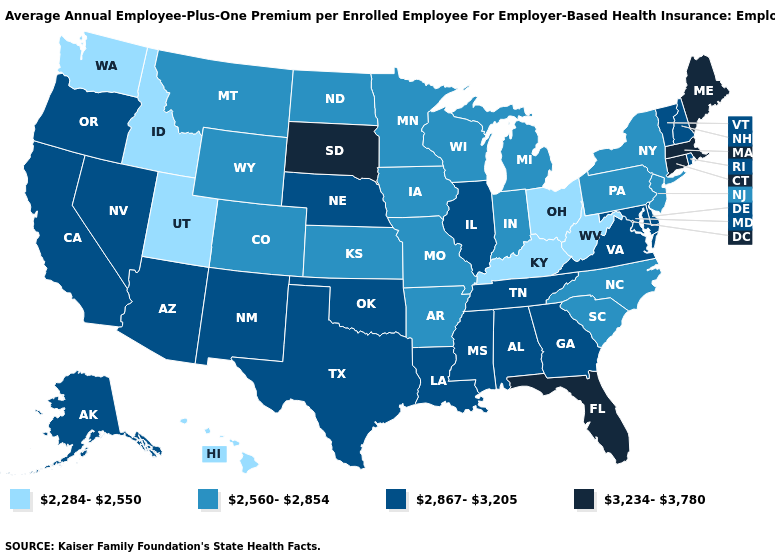Among the states that border West Virginia , which have the lowest value?
Concise answer only. Kentucky, Ohio. Which states have the highest value in the USA?
Give a very brief answer. Connecticut, Florida, Maine, Massachusetts, South Dakota. Does the first symbol in the legend represent the smallest category?
Be succinct. Yes. Among the states that border New Mexico , does Oklahoma have the lowest value?
Concise answer only. No. Which states hav the highest value in the MidWest?
Concise answer only. South Dakota. Does South Dakota have the highest value in the USA?
Write a very short answer. Yes. What is the value of North Carolina?
Give a very brief answer. 2,560-2,854. Name the states that have a value in the range 2,284-2,550?
Give a very brief answer. Hawaii, Idaho, Kentucky, Ohio, Utah, Washington, West Virginia. What is the value of Wisconsin?
Give a very brief answer. 2,560-2,854. What is the value of Utah?
Write a very short answer. 2,284-2,550. What is the lowest value in the South?
Short answer required. 2,284-2,550. Name the states that have a value in the range 2,284-2,550?
Be succinct. Hawaii, Idaho, Kentucky, Ohio, Utah, Washington, West Virginia. Name the states that have a value in the range 3,234-3,780?
Write a very short answer. Connecticut, Florida, Maine, Massachusetts, South Dakota. Which states have the highest value in the USA?
Write a very short answer. Connecticut, Florida, Maine, Massachusetts, South Dakota. Which states have the highest value in the USA?
Be succinct. Connecticut, Florida, Maine, Massachusetts, South Dakota. 